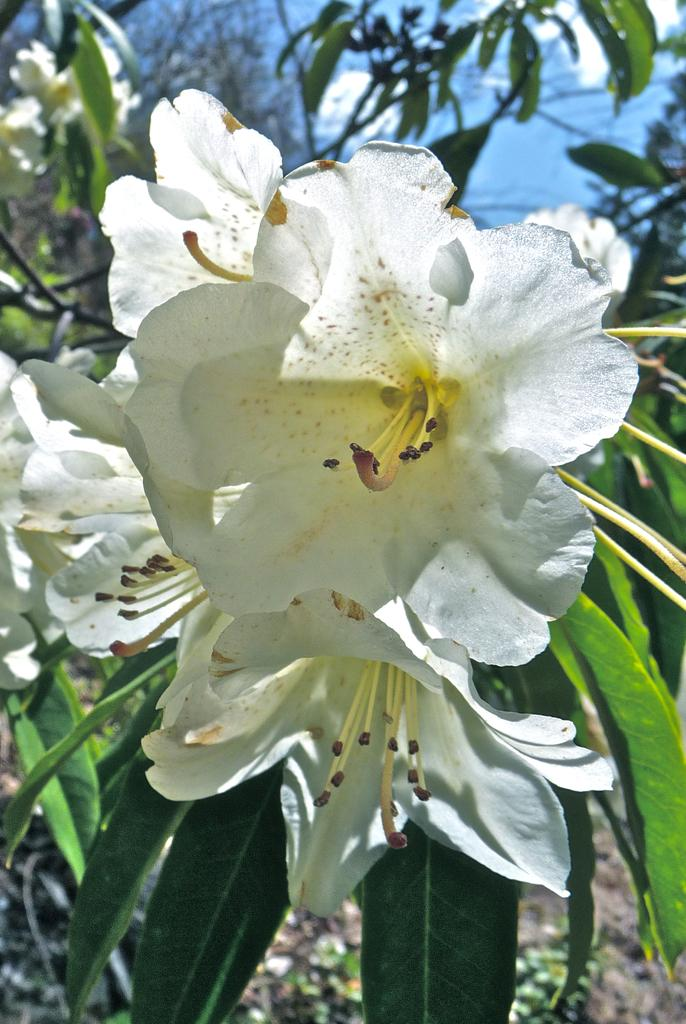What type of plants can be seen in the image? There are flowers in the image. What color are the flowers? The flowers are white in color. Are there any other parts of the plants visible in the image? Yes, there are leaves associated with the flowers. What type of copper material can be seen in the image? There is no copper material present in the image; it features white flowers and leaves. What is the condition of the wax in the image? There is no wax present in the image. 